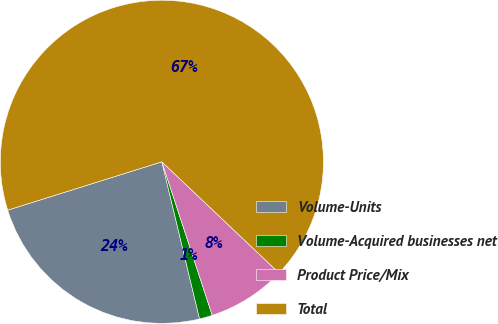Convert chart. <chart><loc_0><loc_0><loc_500><loc_500><pie_chart><fcel>Volume-Units<fcel>Volume-Acquired businesses net<fcel>Product Price/Mix<fcel>Total<nl><fcel>23.91%<fcel>1.3%<fcel>7.87%<fcel>66.92%<nl></chart> 